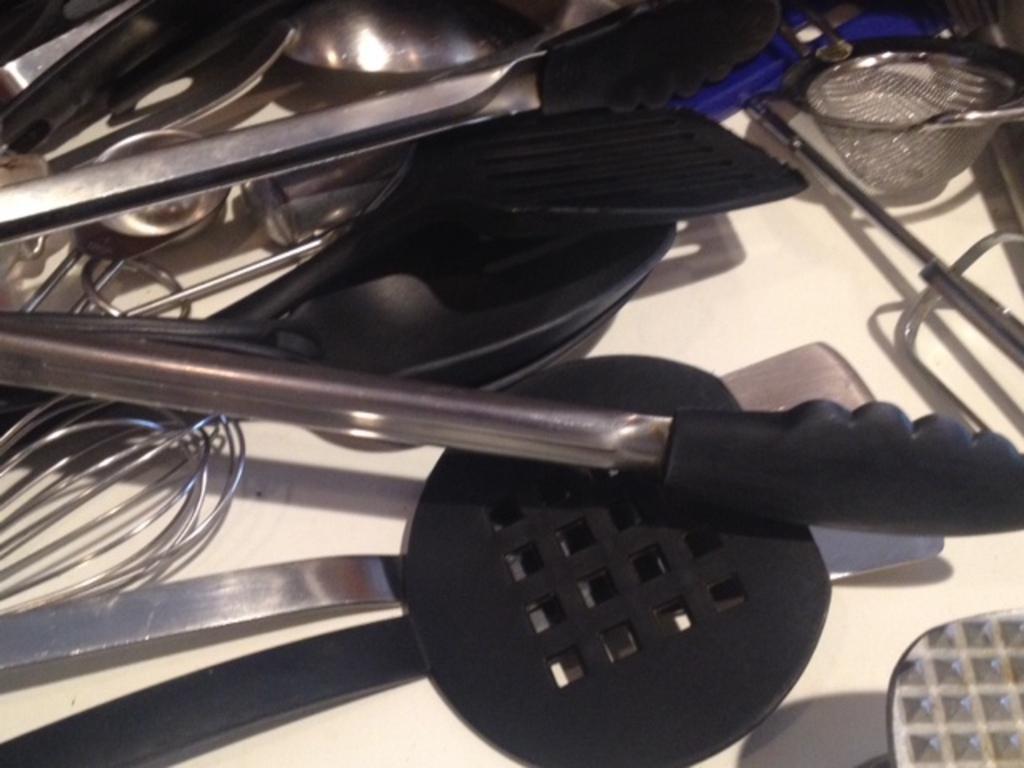Could you give a brief overview of what you see in this image? In this image I can see many utensils and spoons. These spoons are in black color. These are on the white color surface. 